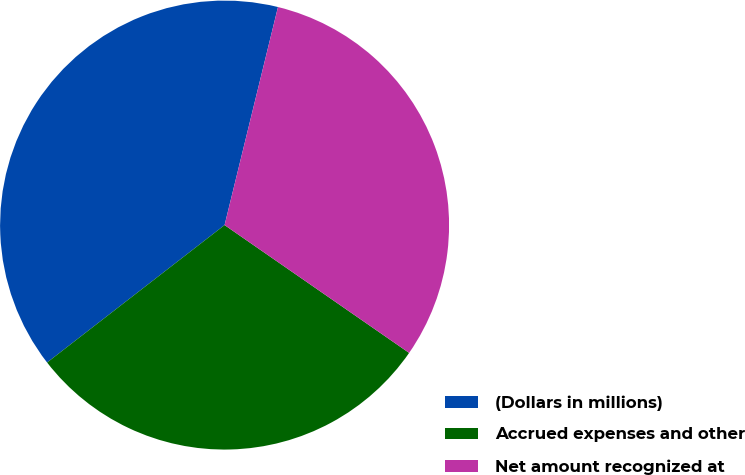Convert chart. <chart><loc_0><loc_0><loc_500><loc_500><pie_chart><fcel>(Dollars in millions)<fcel>Accrued expenses and other<fcel>Net amount recognized at<nl><fcel>39.31%<fcel>29.87%<fcel>30.82%<nl></chart> 